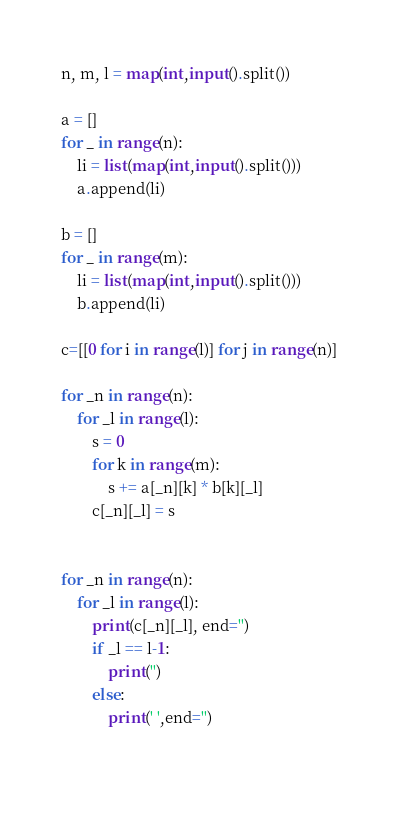<code> <loc_0><loc_0><loc_500><loc_500><_Python_>n, m, l = map(int,input().split())

a = []
for _ in range(n):
    li = list(map(int,input().split()))
    a.append(li)

b = []
for _ in range(m):
    li = list(map(int,input().split()))
    b.append(li)

c=[[0 for i in range(l)] for j in range(n)]

for _n in range(n):
    for _l in range(l):
        s = 0
        for k in range(m):
            s += a[_n][k] * b[k][_l]
        c[_n][_l] = s


for _n in range(n):
    for _l in range(l):
        print(c[_n][_l], end='')
        if _l == l-1:
            print('')
        else:
            print(' ',end='')

    
</code> 